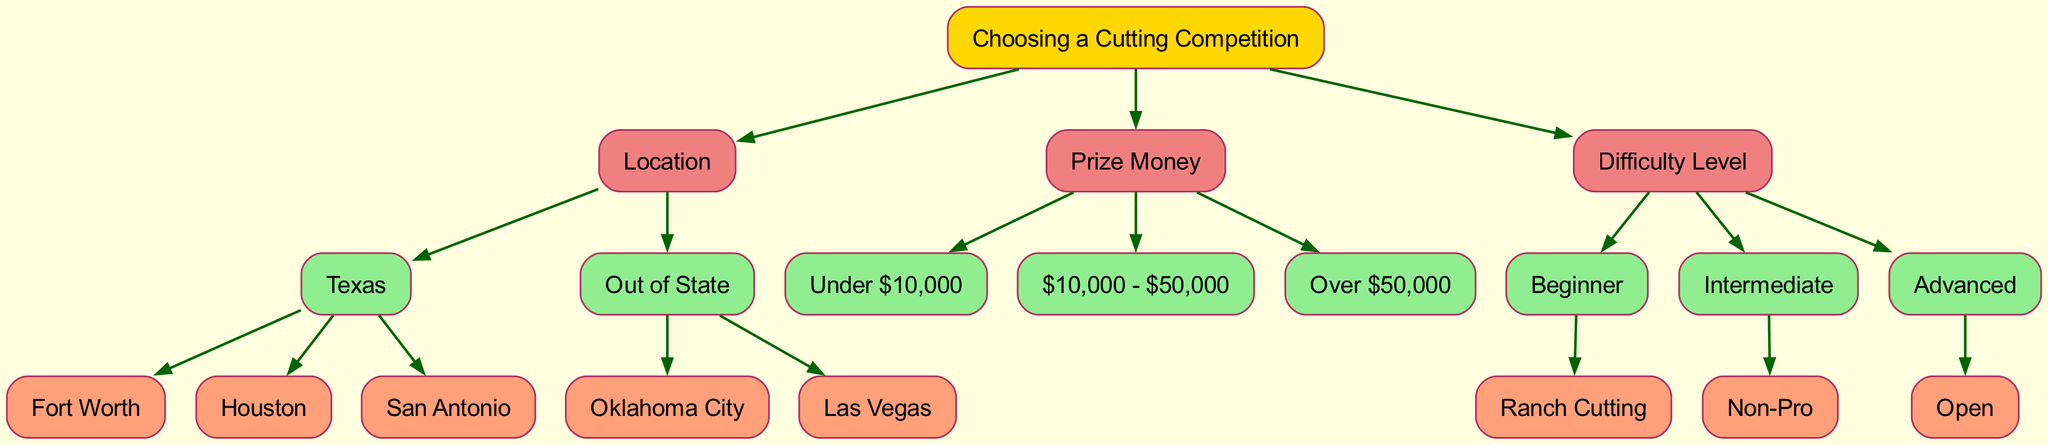What are the locations listed under Texas? The diagram shows that under the "Texas" node, there are three child nodes: "Fort Worth," "Houston," and "San Antonio." These indicate the specific locations for cutting competitions in Texas.
Answer: Fort Worth, Houston, San Antonio How many difficulty levels are there in total? The diagram includes three main categories of difficulty levels: "Beginner," "Intermediate," and "Advanced." Each category has one child node, making a total of three difficulty levels.
Answer: 3 Which node represents the highest prize money? According to the diagram, the node labeled "Over $50,000" signifies the highest range of prize money available in cutting competitions.
Answer: Over $50,000 What is the relationship between the nodes "Texas" and "Oklahoma City"? In the diagram, "Texas" and "Oklahoma City" are related through the "Location" node. The node "Texas" is a child of the main root, whereas "Oklahoma City" falls under the "Out of State" child node, indicating they are branch locations but within the same category of "Location."
Answer: Different categories under Location What kind of cutting competition is classified as "Beginner"? The diagram states that under "Beginner," the specific child node presented is "Ranch Cutting," indicating this is the noted type of cutting competition suitable for beginners.
Answer: Ranch Cutting Which node branches out from "Intermediate" difficulty? The node that extends from "Intermediate" difficulty is labeled "Non-Pro," indicating the type of competition available at this skill level.
Answer: Non-Pro What is the sequence of nodes if I select "San Antonio" and then "Under $10,000"? If you choose "San Antonio," this takes you down to a specific location node. Then, selecting "Under $10,000" will dwell together in context as both selections are sub-nodes under their respective parent nodes, showing the entry level for competitions in that location and prize money range.
Answer: San Antonio, Under $10,000 Which locations have been specified in the out-of-state category? The diagram clearly indicates that the out-of-state category includes "Oklahoma City" and "Las Vegas," both designated as alternate locations for competitions outside Texas.
Answer: Oklahoma City, Las Vegas 